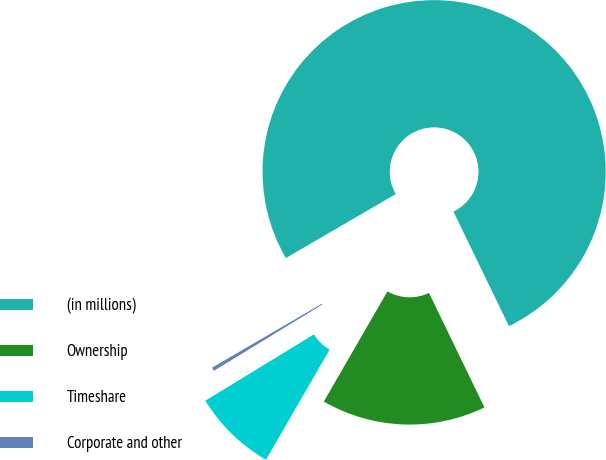Convert chart. <chart><loc_0><loc_0><loc_500><loc_500><pie_chart><fcel>(in millions)<fcel>Ownership<fcel>Timeshare<fcel>Corporate and other<nl><fcel>76.22%<fcel>15.52%<fcel>7.93%<fcel>0.34%<nl></chart> 